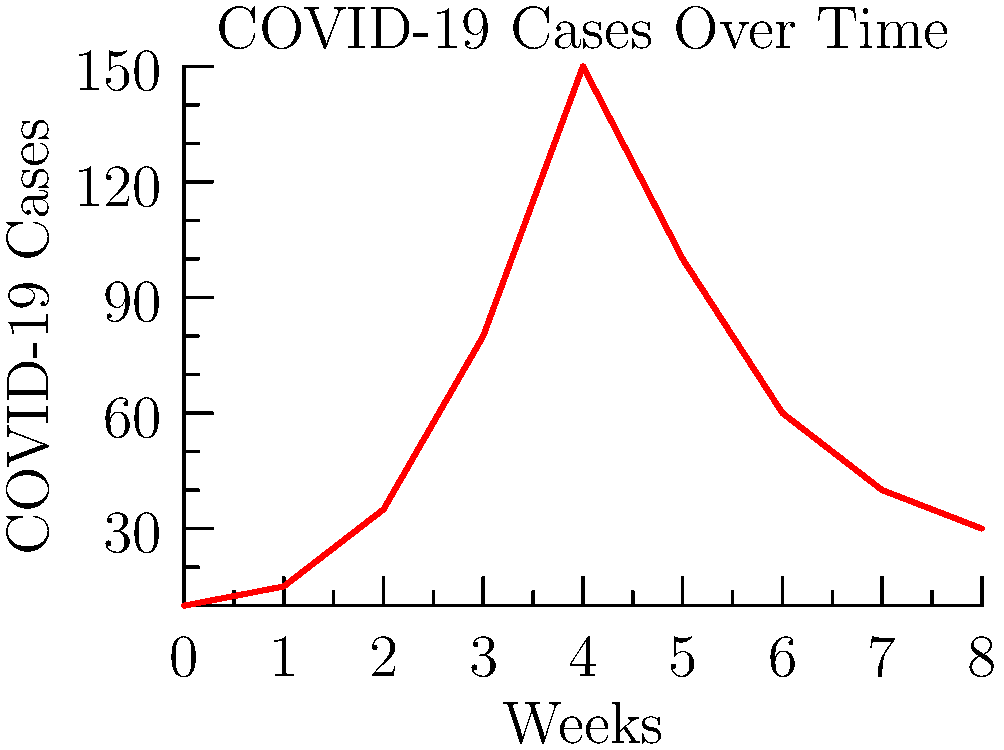Based on the line graph showing COVID-19 case trends over 8 weeks, at which point should you consider implementing stricter safety protocols in your bakery, assuming you want to act proactively when cases are rising but before they reach their peak? To answer this question, we need to analyze the trend in the graph and identify the point where cases are rising significantly but haven't yet reached their peak. Let's break it down step-by-step:

1. Observe the overall trend: The graph shows an initial increase in cases, followed by a peak, and then a decline.

2. Identify the peak: The highest point on the graph occurs at week 4, with approximately 150 cases.

3. Analyze the rising trend: 
   - Week 0 to 1: Slight increase (10 to 15 cases)
   - Week 1 to 2: Moderate increase (15 to 35 cases)
   - Week 2 to 3: Sharp increase (35 to 80 cases)
   - Week 3 to 4: Continued sharp increase (80 to 150 cases)

4. Determine the proactive point: The ideal time to implement stricter protocols would be when there's a clear indication of rapid growth, but before the situation becomes critical. This occurs between weeks 2 and 3, where we see the first sharp increase from 35 to 80 cases.

5. Consider bakery operations: As a bakery owner, you'd want to act quickly to protect staff and customers, but also balance this with operational needs. Implementing changes at week 2 gives you time to adjust before the case count becomes very high.

Therefore, the most appropriate time to implement stricter safety protocols would be at week 2, when cases have risen to 35 and are showing signs of rapid increase.
Answer: Week 2 